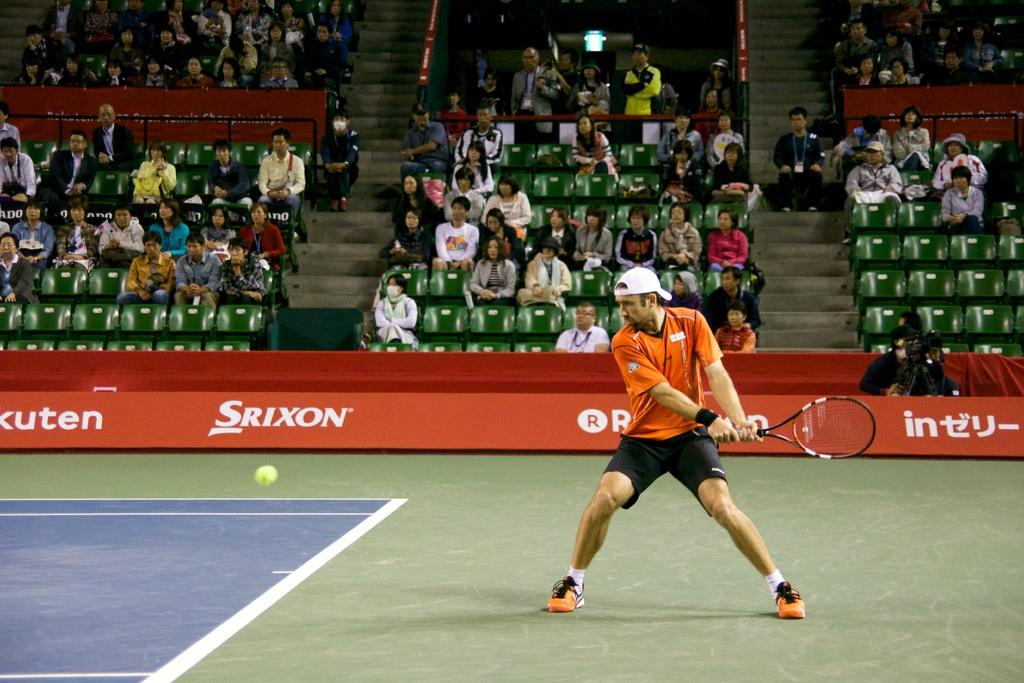<image>
Relay a brief, clear account of the picture shown. A tennis player waiting to return the ball in front of a Srixon advertisement. 